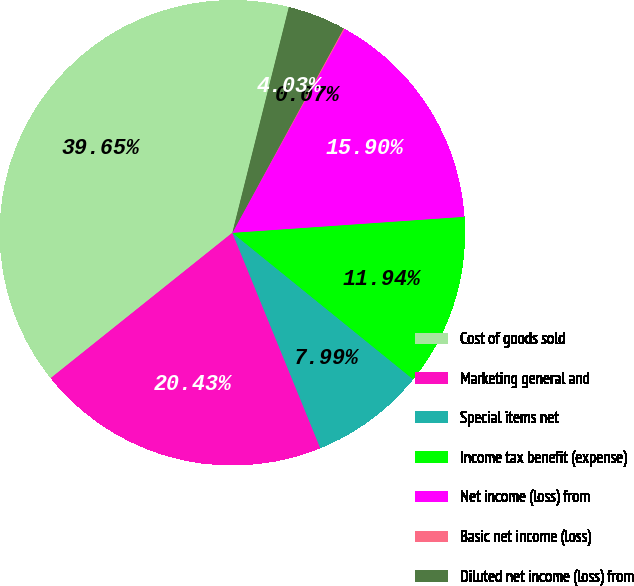Convert chart to OTSL. <chart><loc_0><loc_0><loc_500><loc_500><pie_chart><fcel>Cost of goods sold<fcel>Marketing general and<fcel>Special items net<fcel>Income tax benefit (expense)<fcel>Net income (loss) from<fcel>Basic net income (loss)<fcel>Diluted net income (loss) from<nl><fcel>39.65%<fcel>20.43%<fcel>7.99%<fcel>11.94%<fcel>15.9%<fcel>0.07%<fcel>4.03%<nl></chart> 